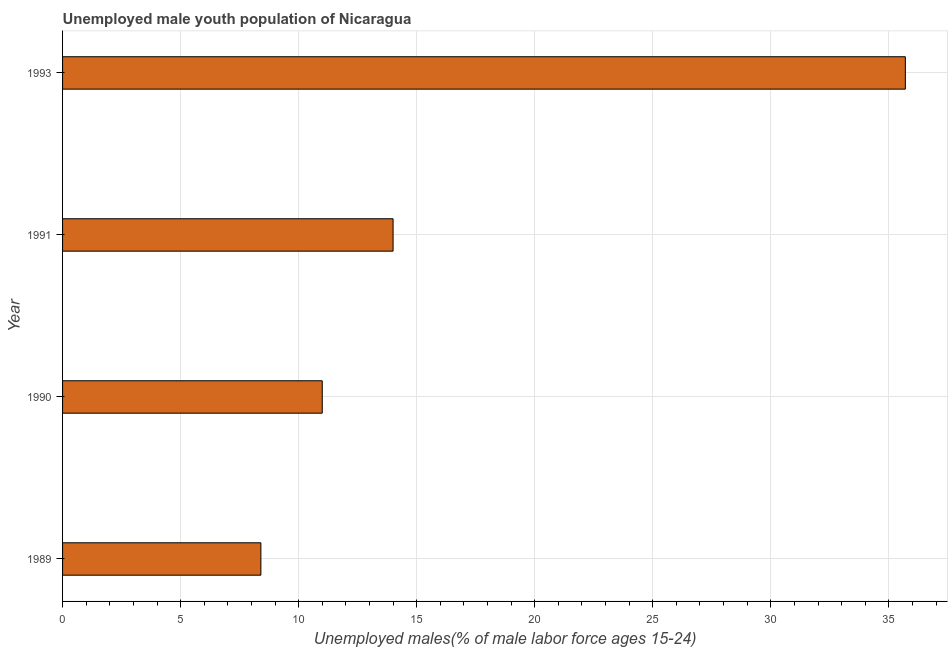Does the graph contain any zero values?
Offer a terse response. No. What is the title of the graph?
Your answer should be compact. Unemployed male youth population of Nicaragua. What is the label or title of the X-axis?
Give a very brief answer. Unemployed males(% of male labor force ages 15-24). What is the unemployed male youth in 1993?
Your response must be concise. 35.7. Across all years, what is the maximum unemployed male youth?
Make the answer very short. 35.7. Across all years, what is the minimum unemployed male youth?
Keep it short and to the point. 8.4. In which year was the unemployed male youth minimum?
Keep it short and to the point. 1989. What is the sum of the unemployed male youth?
Your response must be concise. 69.1. What is the average unemployed male youth per year?
Make the answer very short. 17.27. What is the median unemployed male youth?
Your answer should be very brief. 12.5. What is the ratio of the unemployed male youth in 1989 to that in 1993?
Provide a short and direct response. 0.23. Is the unemployed male youth in 1989 less than that in 1993?
Make the answer very short. Yes. Is the difference between the unemployed male youth in 1989 and 1991 greater than the difference between any two years?
Your response must be concise. No. What is the difference between the highest and the second highest unemployed male youth?
Keep it short and to the point. 21.7. Is the sum of the unemployed male youth in 1989 and 1990 greater than the maximum unemployed male youth across all years?
Make the answer very short. No. What is the difference between the highest and the lowest unemployed male youth?
Provide a short and direct response. 27.3. In how many years, is the unemployed male youth greater than the average unemployed male youth taken over all years?
Your answer should be very brief. 1. Are the values on the major ticks of X-axis written in scientific E-notation?
Make the answer very short. No. What is the Unemployed males(% of male labor force ages 15-24) of 1989?
Ensure brevity in your answer.  8.4. What is the Unemployed males(% of male labor force ages 15-24) of 1991?
Give a very brief answer. 14. What is the Unemployed males(% of male labor force ages 15-24) in 1993?
Keep it short and to the point. 35.7. What is the difference between the Unemployed males(% of male labor force ages 15-24) in 1989 and 1991?
Give a very brief answer. -5.6. What is the difference between the Unemployed males(% of male labor force ages 15-24) in 1989 and 1993?
Make the answer very short. -27.3. What is the difference between the Unemployed males(% of male labor force ages 15-24) in 1990 and 1991?
Provide a succinct answer. -3. What is the difference between the Unemployed males(% of male labor force ages 15-24) in 1990 and 1993?
Ensure brevity in your answer.  -24.7. What is the difference between the Unemployed males(% of male labor force ages 15-24) in 1991 and 1993?
Offer a very short reply. -21.7. What is the ratio of the Unemployed males(% of male labor force ages 15-24) in 1989 to that in 1990?
Keep it short and to the point. 0.76. What is the ratio of the Unemployed males(% of male labor force ages 15-24) in 1989 to that in 1993?
Your answer should be very brief. 0.23. What is the ratio of the Unemployed males(% of male labor force ages 15-24) in 1990 to that in 1991?
Your answer should be very brief. 0.79. What is the ratio of the Unemployed males(% of male labor force ages 15-24) in 1990 to that in 1993?
Your answer should be compact. 0.31. What is the ratio of the Unemployed males(% of male labor force ages 15-24) in 1991 to that in 1993?
Offer a very short reply. 0.39. 